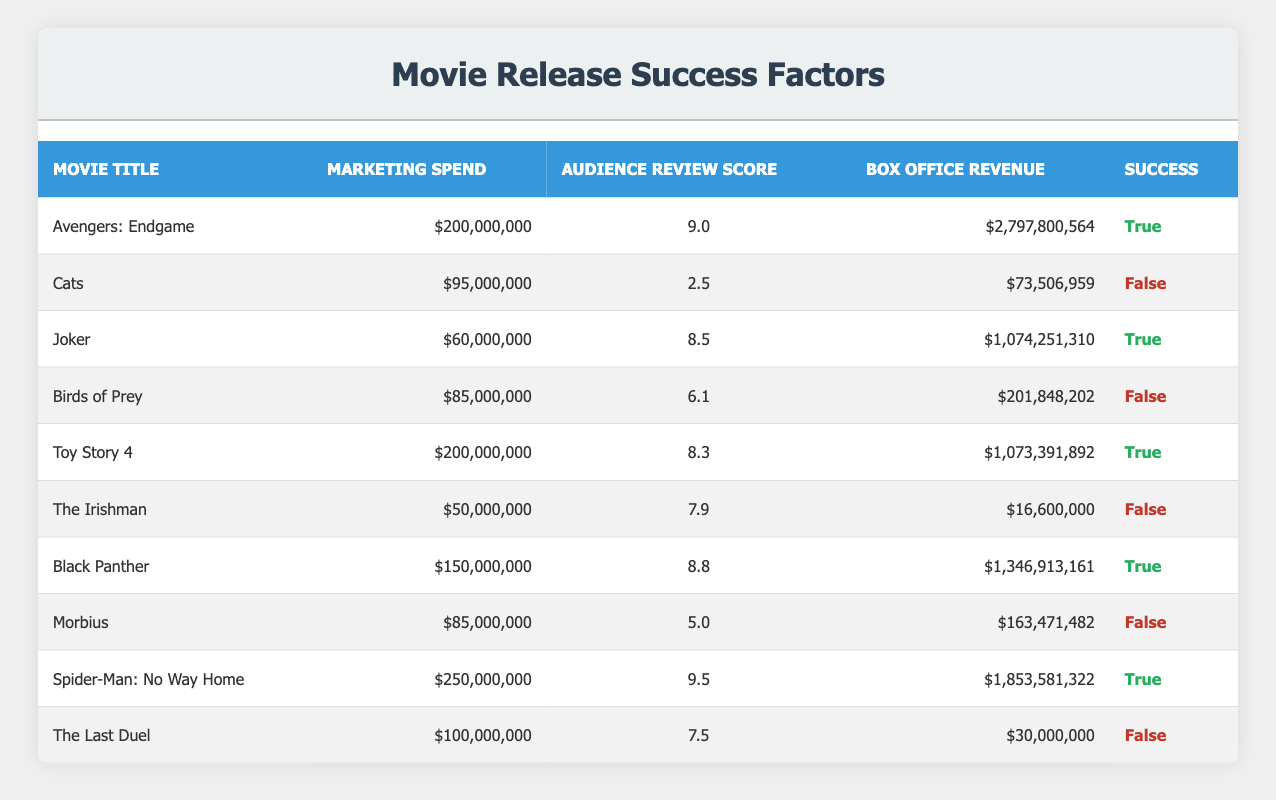What is the marketing spend for "Black Panther"? The table shows the row for "Black Panther," and the corresponding marketing spend listed is $150,000,000.
Answer: $150,000,000 Which movie had the highest audience review score? By examining the Audience Review Score column, "Spider-Man: No Way Home" with a score of 9.5 is the highest among all movies listed.
Answer: 9.5 What is the total box office revenue for movies that were successful? To find the total box office revenue, we sum the box office revenues of successful movies: Avengers: Endgame ($2,797,800,564) + Joker ($1,074,251,310) + Toy Story 4 ($1,073,391,892) + Black Panther ($1,346,913,161) + Spider-Man: No Way Home ($1,853,581,322) = $8,145,926,249.
Answer: $8,145,926,249 Did "Cats" succeed at the box office? The table indicates that "Cats" has a success status of False, meaning it did not succeed at the box office.
Answer: No What is the average marketing spend for the movies that failed? To find the average marketing spend for unsuccessful movies: We gather the marketing spends of Cats ($95,000,000), Birds of Prey ($85,000,000), The Irishman ($50,000,000), Morbius ($85,000,000), and The Last Duel ($100,000,000), summing them gives $415,000,000, and then dividing by 5 results in an average of $83,000,000.
Answer: $83,000,000 How many movies had a marketing spend of over $200 million? From the table, only "Avengers: Endgame" and "Spider-Man: No Way Home" are listed with marketing spends above $200 million, totaling 2 movies.
Answer: 2 Which successful movie had the lowest marketing spend? By examining the table, "Joker" is the successful movie with a marketing spend of $60,000,000, which is lower than the marketing spends of other successful movies.
Answer: $60,000,000 Did any movie with a marketing spend over $100 million fail? Upon reviewing the table, "Birds of Prey" and "The Last Duel" both had marketing spends over $100 million and have a failure status listed as True, confirming they did not succeed.
Answer: Yes 